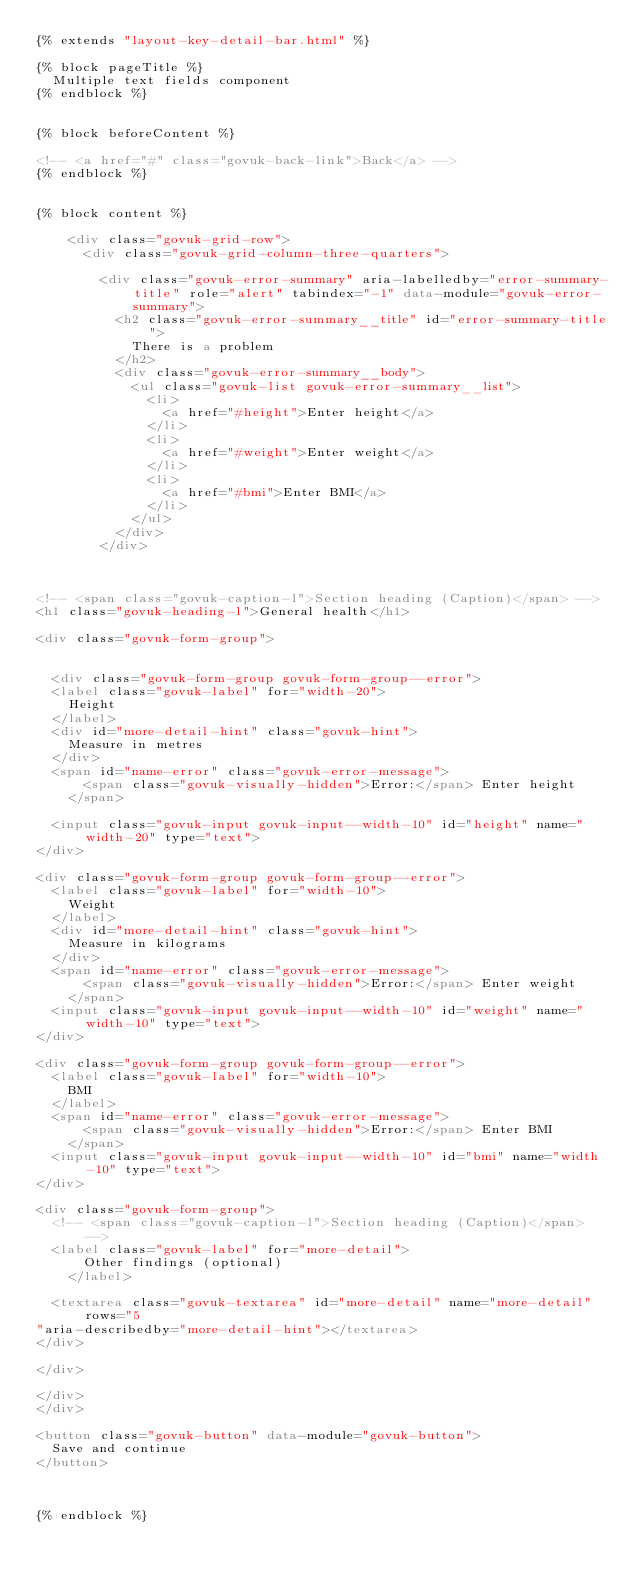<code> <loc_0><loc_0><loc_500><loc_500><_HTML_>{% extends "layout-key-detail-bar.html" %}

{% block pageTitle %}
  Multiple text fields component
{% endblock %}


{% block beforeContent %}

<!-- <a href="#" class="govuk-back-link">Back</a> -->
{% endblock %}


{% block content %}

    <div class="govuk-grid-row">
      <div class="govuk-grid-column-three-quarters">

        <div class="govuk-error-summary" aria-labelledby="error-summary-title" role="alert" tabindex="-1" data-module="govuk-error-summary">
          <h2 class="govuk-error-summary__title" id="error-summary-title">
            There is a problem
          </h2>
          <div class="govuk-error-summary__body">
            <ul class="govuk-list govuk-error-summary__list">
              <li>
                <a href="#height">Enter height</a>
              </li>
              <li>
                <a href="#weight">Enter weight</a>
              </li>
              <li>
                <a href="#bmi">Enter BMI</a>
              </li>
            </ul>
          </div>
        </div>



<!-- <span class="govuk-caption-l">Section heading (Caption)</span> -->
<h1 class="govuk-heading-l">General health</h1>

<div class="govuk-form-group">


  <div class="govuk-form-group govuk-form-group--error">
  <label class="govuk-label" for="width-20">
    Height
  </label>
  <div id="more-detail-hint" class="govuk-hint">
    Measure in metres
  </div>
  <span id="name-error" class="govuk-error-message">
      <span class="govuk-visually-hidden">Error:</span> Enter height
    </span>

  <input class="govuk-input govuk-input--width-10" id="height" name="width-20" type="text">
</div>

<div class="govuk-form-group govuk-form-group--error">
  <label class="govuk-label" for="width-10">
    Weight
  </label>
  <div id="more-detail-hint" class="govuk-hint">
    Measure in kilograms
  </div>
  <span id="name-error" class="govuk-error-message">
      <span class="govuk-visually-hidden">Error:</span> Enter weight
    </span>
  <input class="govuk-input govuk-input--width-10" id="weight" name="width-10" type="text">
</div>

<div class="govuk-form-group govuk-form-group--error">
  <label class="govuk-label" for="width-10">
    BMI
  </label>
  <span id="name-error" class="govuk-error-message">
      <span class="govuk-visually-hidden">Error:</span> Enter BMI
    </span>
  <input class="govuk-input govuk-input--width-10" id="bmi" name="width-10" type="text">
</div>

<div class="govuk-form-group">
  <!-- <span class="govuk-caption-l">Section heading (Caption)</span> -->
  <label class="govuk-label" for="more-detail">
      Other findings (optional)
    </label>

  <textarea class="govuk-textarea" id="more-detail" name="more-detail" rows="5
"aria-describedby="more-detail-hint"></textarea>
</div>

</div>

</div>
</div>

<button class="govuk-button" data-module="govuk-button">
  Save and continue
</button>



{% endblock %}
</code> 